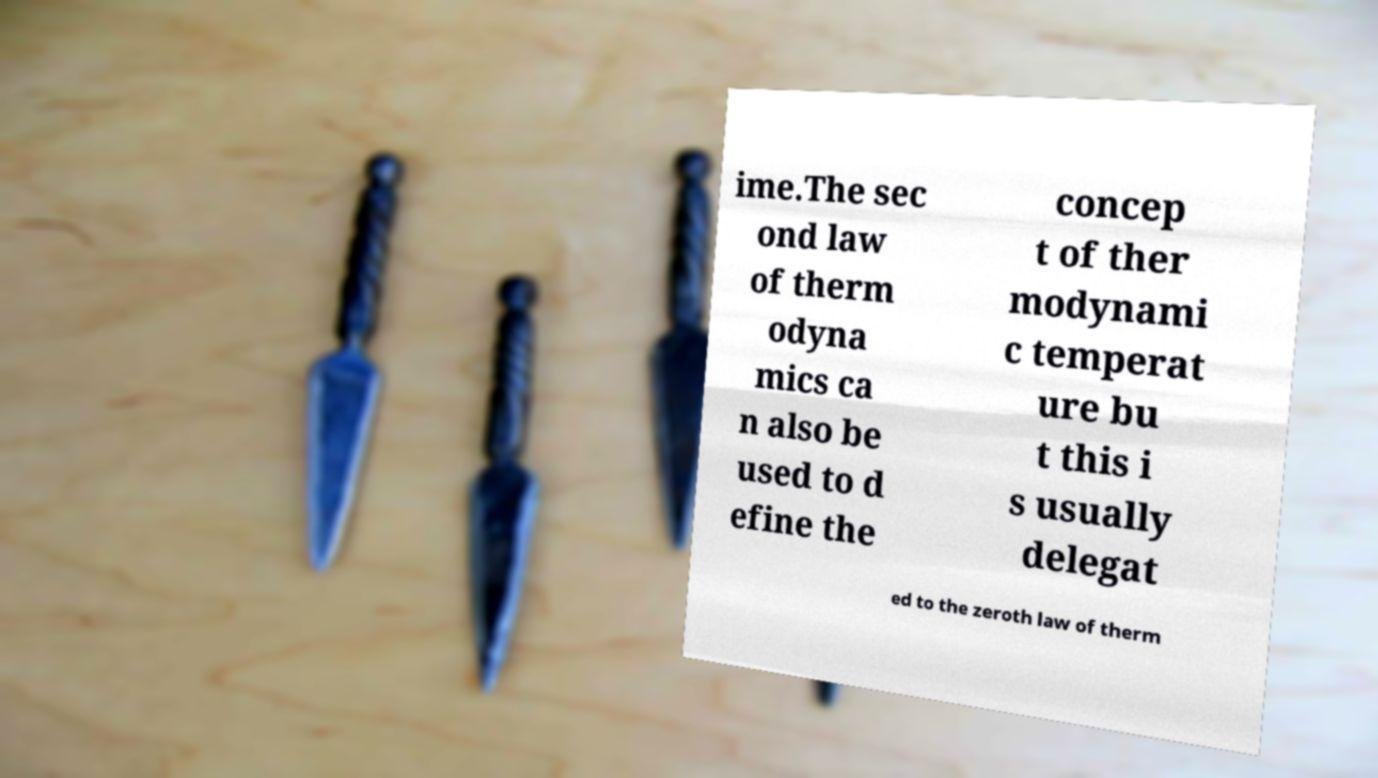Could you extract and type out the text from this image? ime.The sec ond law of therm odyna mics ca n also be used to d efine the concep t of ther modynami c temperat ure bu t this i s usually delegat ed to the zeroth law of therm 